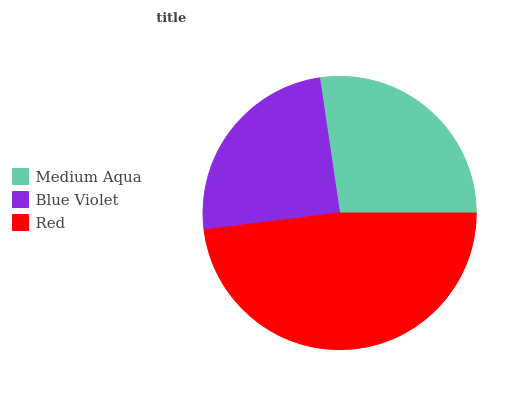Is Blue Violet the minimum?
Answer yes or no. Yes. Is Red the maximum?
Answer yes or no. Yes. Is Red the minimum?
Answer yes or no. No. Is Blue Violet the maximum?
Answer yes or no. No. Is Red greater than Blue Violet?
Answer yes or no. Yes. Is Blue Violet less than Red?
Answer yes or no. Yes. Is Blue Violet greater than Red?
Answer yes or no. No. Is Red less than Blue Violet?
Answer yes or no. No. Is Medium Aqua the high median?
Answer yes or no. Yes. Is Medium Aqua the low median?
Answer yes or no. Yes. Is Blue Violet the high median?
Answer yes or no. No. Is Red the low median?
Answer yes or no. No. 